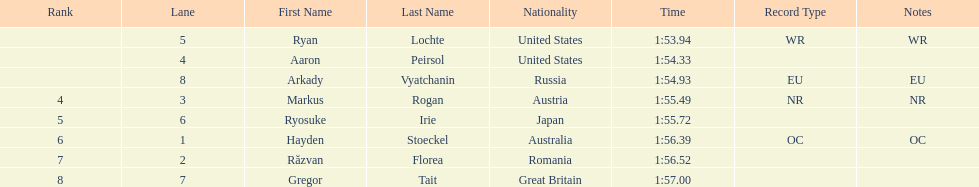Does russia or japan have the longer time? Japan. 